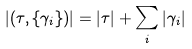Convert formula to latex. <formula><loc_0><loc_0><loc_500><loc_500>| ( \tau , \{ \gamma _ { i } \} ) | = | \tau | + \sum _ { i } | \gamma _ { i } |</formula> 